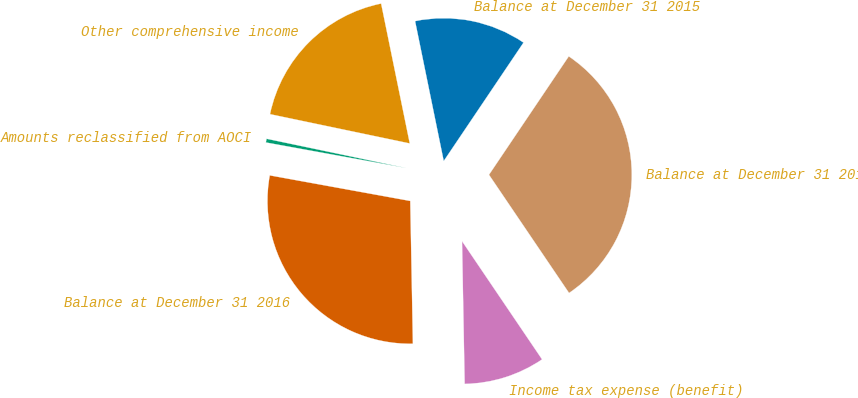Convert chart to OTSL. <chart><loc_0><loc_0><loc_500><loc_500><pie_chart><fcel>Balance at December 31 2015<fcel>Other comprehensive income<fcel>Amounts reclassified from AOCI<fcel>Balance at December 31 2016<fcel>Income tax expense (benefit)<fcel>Balance at December 31 2014<nl><fcel>12.65%<fcel>18.5%<fcel>0.42%<fcel>28.16%<fcel>9.18%<fcel>31.09%<nl></chart> 